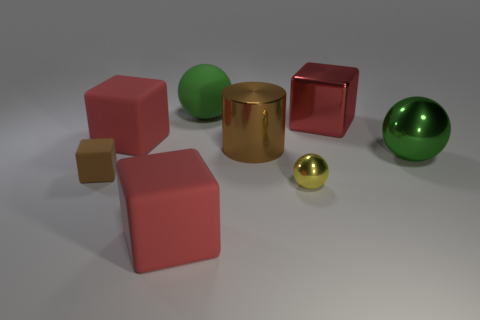Is there a green sphere in front of the cube that is behind the red rubber thing behind the brown rubber block?
Your response must be concise. Yes. What number of cylinders are either big yellow metallic things or big green metallic objects?
Your answer should be compact. 0. What is the red block on the right side of the large brown metallic cylinder made of?
Make the answer very short. Metal. What size is the cylinder that is the same color as the small matte cube?
Your answer should be very brief. Large. There is a shiny object that is in front of the brown rubber block; is it the same color as the ball that is on the right side of the yellow sphere?
Your response must be concise. No. What number of things are tiny green metallic balls or red rubber objects?
Give a very brief answer. 2. How many other objects are the same shape as the big green metal object?
Provide a succinct answer. 2. Do the big sphere behind the green shiny thing and the large red cube right of the big green matte object have the same material?
Ensure brevity in your answer.  No. What is the shape of the matte object that is in front of the big brown shiny object and on the right side of the small brown object?
Your answer should be very brief. Cube. Is there any other thing that is the same material as the tiny yellow object?
Offer a very short reply. Yes. 